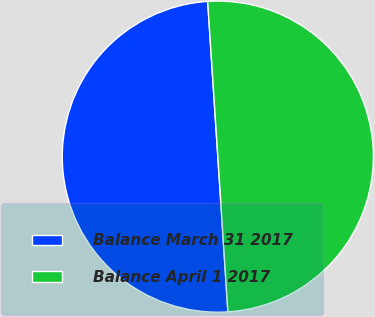Convert chart to OTSL. <chart><loc_0><loc_0><loc_500><loc_500><pie_chart><fcel>Balance March 31 2017<fcel>Balance April 1 2017<nl><fcel>49.99%<fcel>50.01%<nl></chart> 